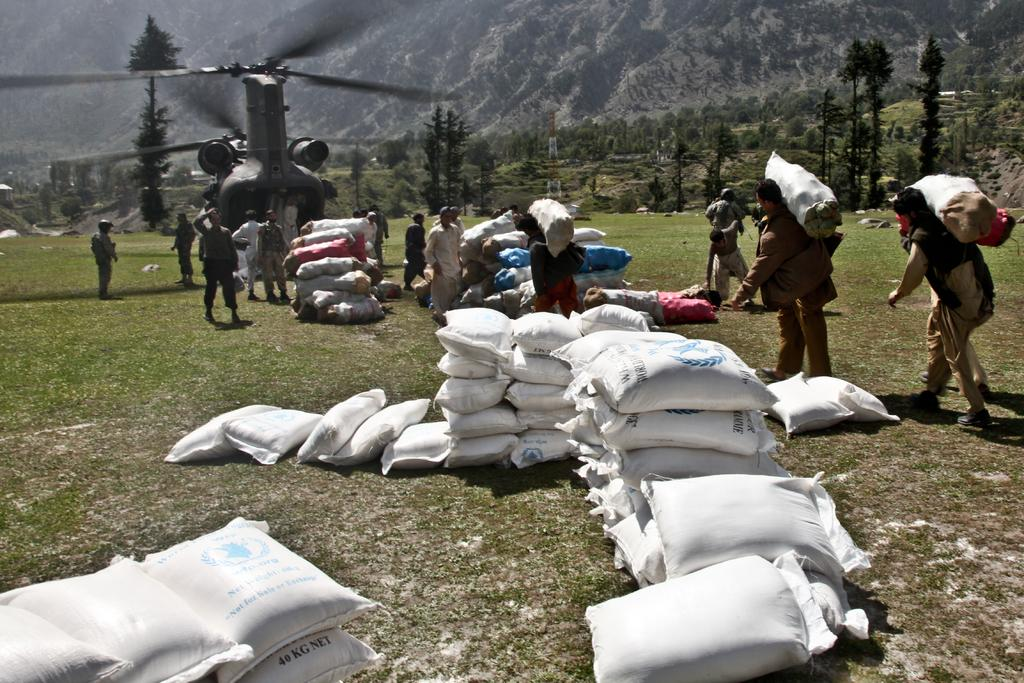What objects are in the foreground of the image? There are sacks in the foreground of the image. What are the people in the image doing? The people in the image are carrying sacks. What type of vehicle is present in the image? There is an aircraft in the image. What can be seen in the background of the image? There are trees and mountains in the background of the image. Can you see any ladybugs crawling on the sacks in the image? There are no ladybugs visible on the sacks in the image. Are any of the people in the image using a wrench to carry the sacks? There is no wrench present in the image, and the people are carrying the sacks using their hands. 